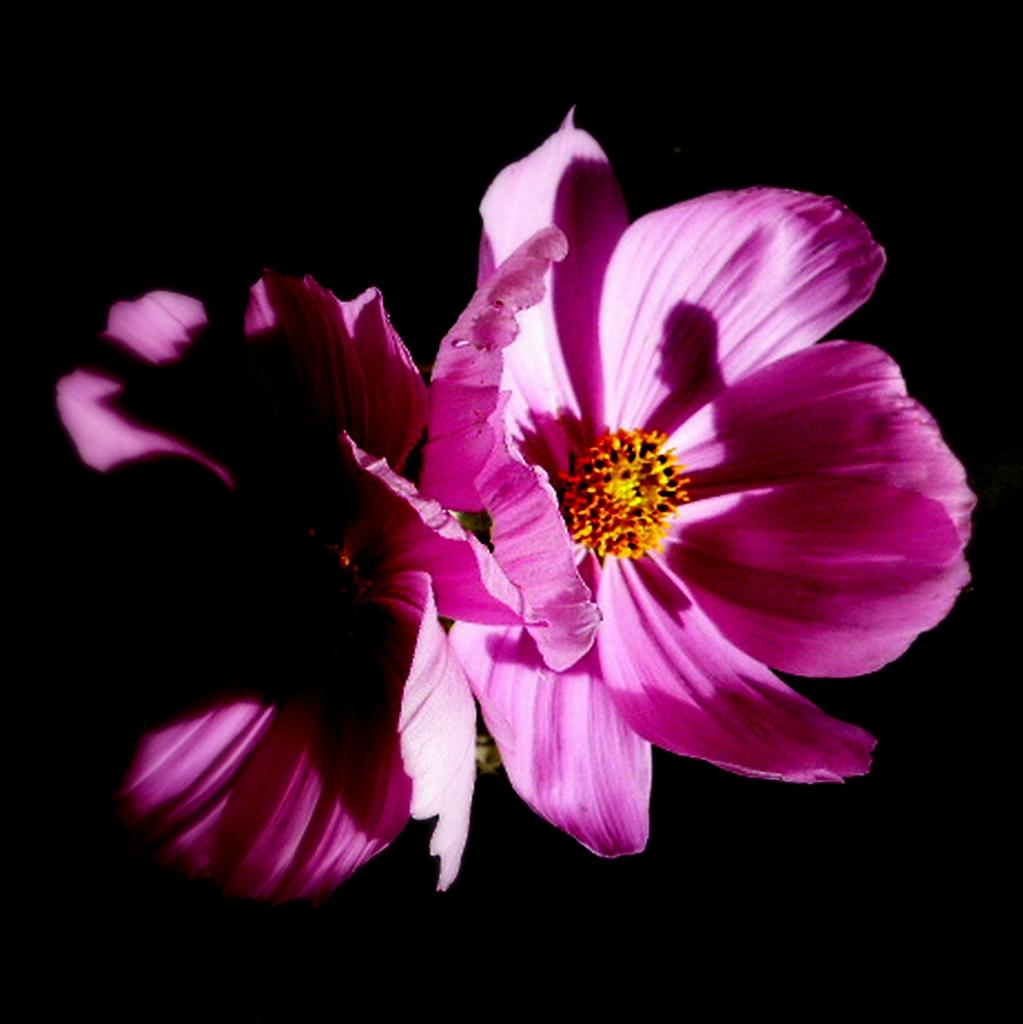What type of flowers can be seen in the image? There are pink color flowers in the image. What book is the flower reading in the image? There is no book or reading activity present in the image, as it features only flowers. 